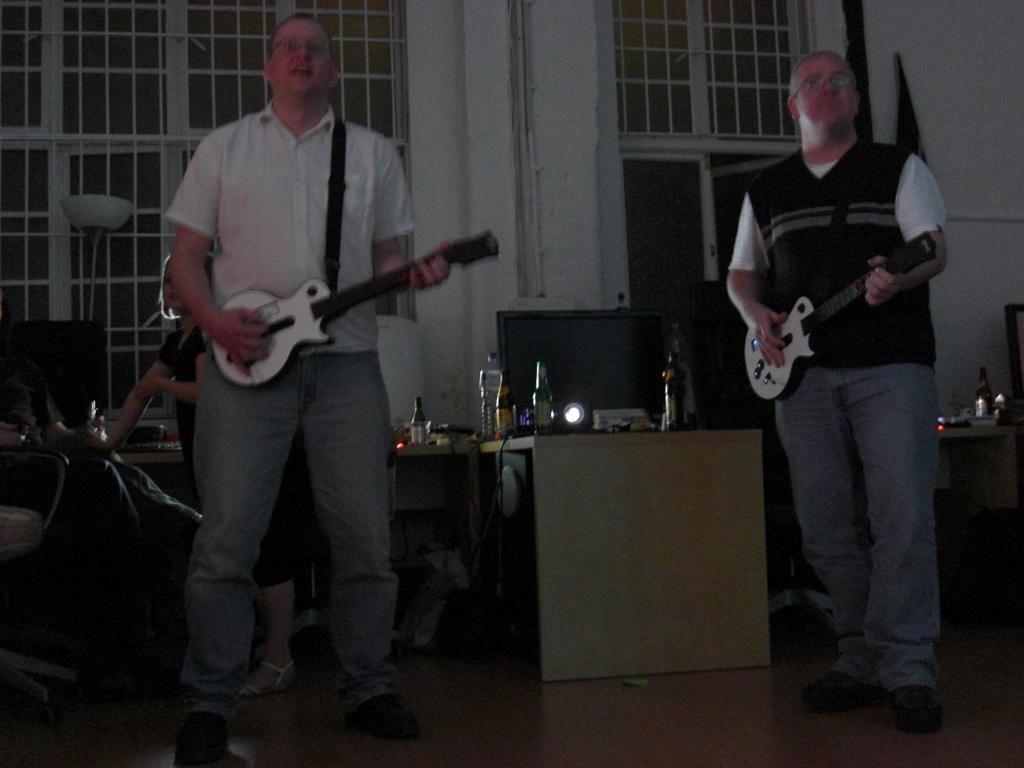In one or two sentences, can you explain what this image depicts? In this picture we can see two persons holding guitar and they are singing,beside them there is a table with different items such as bottle,light etc. Back of the person there was a small kid holding a thing. 